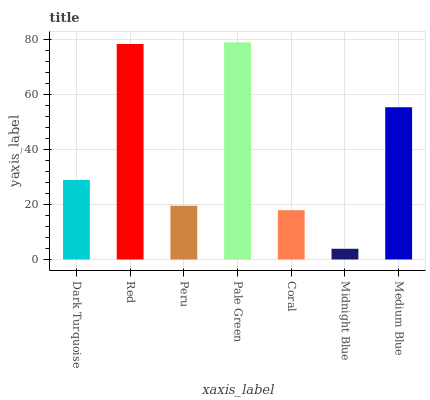Is Midnight Blue the minimum?
Answer yes or no. Yes. Is Pale Green the maximum?
Answer yes or no. Yes. Is Red the minimum?
Answer yes or no. No. Is Red the maximum?
Answer yes or no. No. Is Red greater than Dark Turquoise?
Answer yes or no. Yes. Is Dark Turquoise less than Red?
Answer yes or no. Yes. Is Dark Turquoise greater than Red?
Answer yes or no. No. Is Red less than Dark Turquoise?
Answer yes or no. No. Is Dark Turquoise the high median?
Answer yes or no. Yes. Is Dark Turquoise the low median?
Answer yes or no. Yes. Is Pale Green the high median?
Answer yes or no. No. Is Peru the low median?
Answer yes or no. No. 